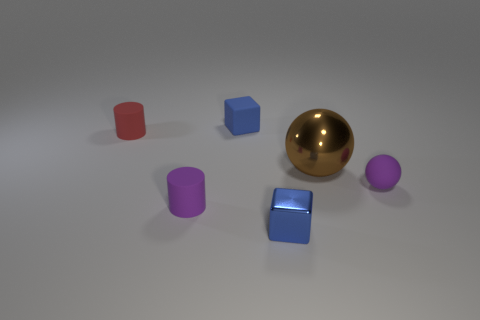Add 1 brown metallic things. How many objects exist? 7 Subtract all cylinders. How many objects are left? 4 Subtract 0 gray cubes. How many objects are left? 6 Subtract all blue matte objects. Subtract all matte balls. How many objects are left? 4 Add 2 tiny blue metal blocks. How many tiny blue metal blocks are left? 3 Add 2 big green rubber objects. How many big green rubber objects exist? 2 